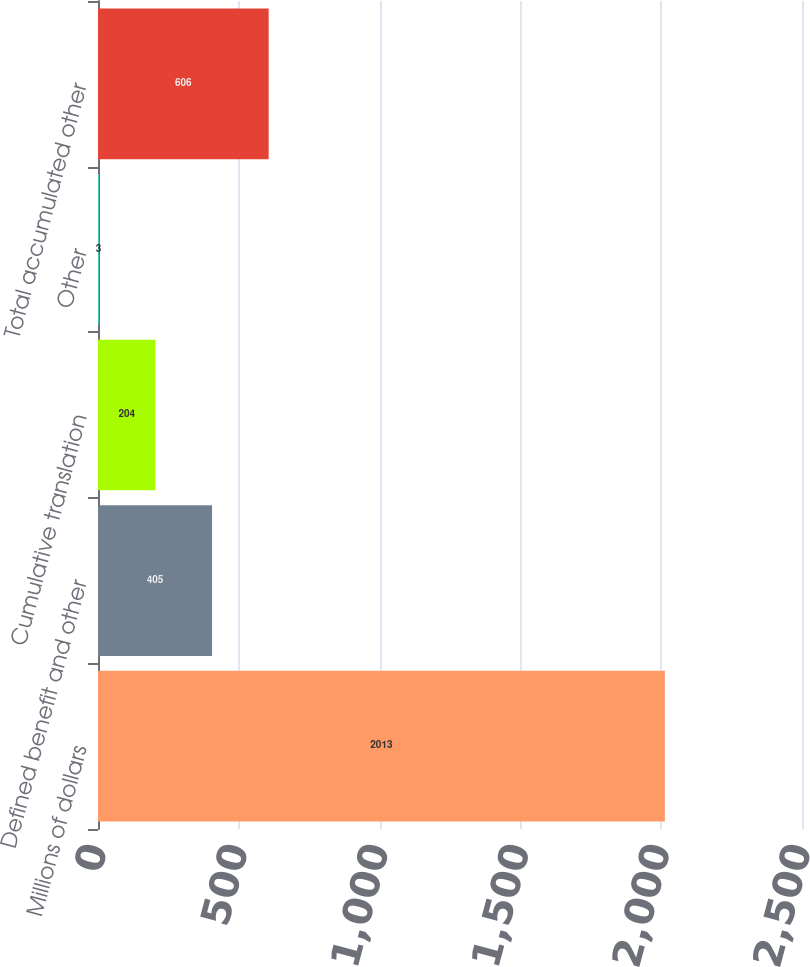Convert chart to OTSL. <chart><loc_0><loc_0><loc_500><loc_500><bar_chart><fcel>Millions of dollars<fcel>Defined benefit and other<fcel>Cumulative translation<fcel>Other<fcel>Total accumulated other<nl><fcel>2013<fcel>405<fcel>204<fcel>3<fcel>606<nl></chart> 